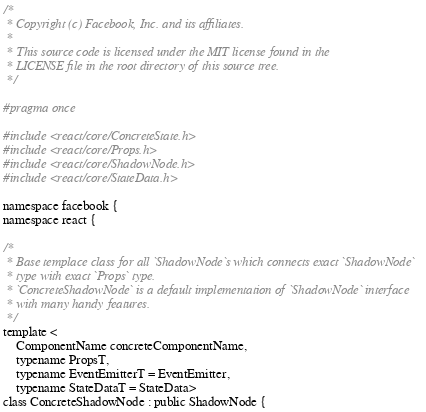Convert code to text. <code><loc_0><loc_0><loc_500><loc_500><_C_>/*
 * Copyright (c) Facebook, Inc. and its affiliates.
 *
 * This source code is licensed under the MIT license found in the
 * LICENSE file in the root directory of this source tree.
 */

#pragma once

#include <react/core/ConcreteState.h>
#include <react/core/Props.h>
#include <react/core/ShadowNode.h>
#include <react/core/StateData.h>

namespace facebook {
namespace react {

/*
 * Base templace class for all `ShadowNode`s which connects exact `ShadowNode`
 * type with exact `Props` type.
 * `ConcreteShadowNode` is a default implementation of `ShadowNode` interface
 * with many handy features.
 */
template <
    ComponentName concreteComponentName,
    typename PropsT,
    typename EventEmitterT = EventEmitter,
    typename StateDataT = StateData>
class ConcreteShadowNode : public ShadowNode {</code> 